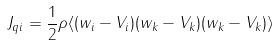<formula> <loc_0><loc_0><loc_500><loc_500>J _ { q i } = { \frac { 1 } { 2 } } \rho \langle ( w _ { i } - V _ { i } ) ( w _ { k } - V _ { k } ) ( w _ { k } - V _ { k } ) \rangle</formula> 